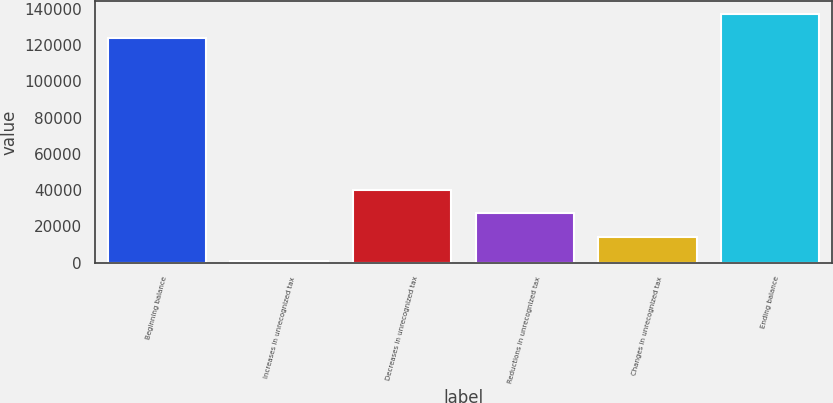<chart> <loc_0><loc_0><loc_500><loc_500><bar_chart><fcel>Beginning balance<fcel>Increases in unrecognized tax<fcel>Decreases in unrecognized tax<fcel>Reductions in unrecognized tax<fcel>Changes in unrecognized tax<fcel>Ending balance<nl><fcel>124102<fcel>976<fcel>40299.4<fcel>27191.6<fcel>14083.8<fcel>137210<nl></chart> 